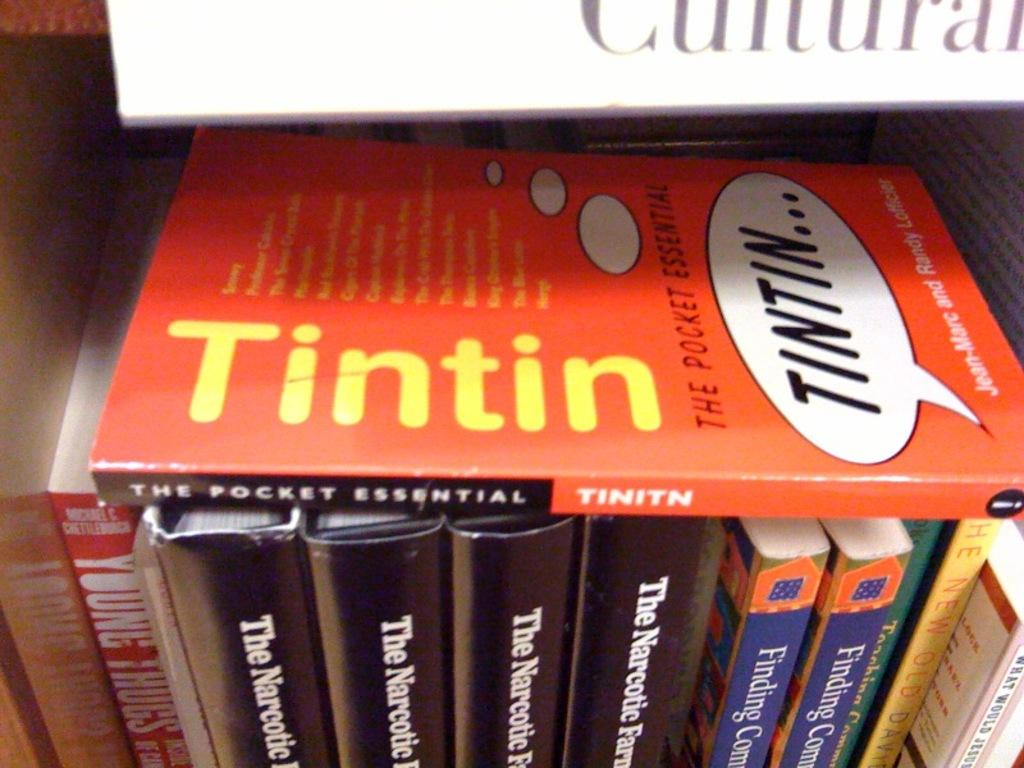<image>
Describe the image concisely. A Tintin book sits on top of several other books on a shelf. 